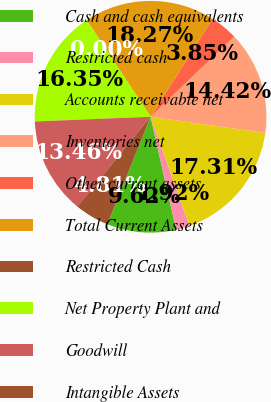<chart> <loc_0><loc_0><loc_500><loc_500><pie_chart><fcel>Cash and cash equivalents<fcel>Restricted cash<fcel>Accounts receivable net<fcel>Inventories net<fcel>Other current assets<fcel>Total Current Assets<fcel>Restricted Cash<fcel>Net Property Plant and<fcel>Goodwill<fcel>Intangible Assets<nl><fcel>9.62%<fcel>1.92%<fcel>17.31%<fcel>14.42%<fcel>3.85%<fcel>18.27%<fcel>0.0%<fcel>16.35%<fcel>13.46%<fcel>4.81%<nl></chart> 